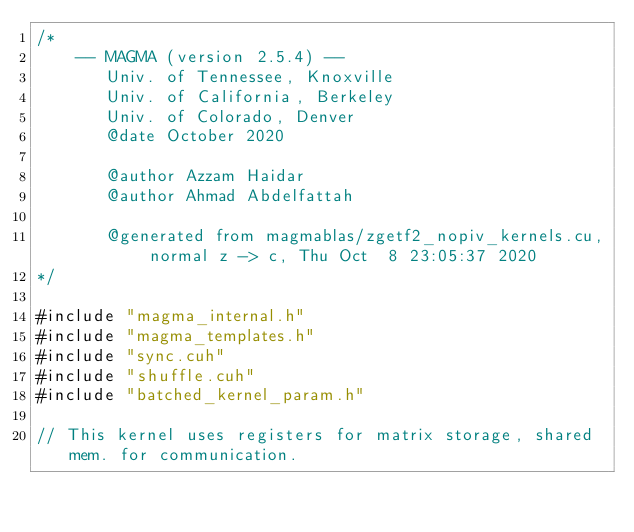<code> <loc_0><loc_0><loc_500><loc_500><_Cuda_>/*
    -- MAGMA (version 2.5.4) --
       Univ. of Tennessee, Knoxville
       Univ. of California, Berkeley
       Univ. of Colorado, Denver
       @date October 2020

       @author Azzam Haidar
       @author Ahmad Abdelfattah

       @generated from magmablas/zgetf2_nopiv_kernels.cu, normal z -> c, Thu Oct  8 23:05:37 2020
*/

#include "magma_internal.h"
#include "magma_templates.h"
#include "sync.cuh"
#include "shuffle.cuh"
#include "batched_kernel_param.h"

// This kernel uses registers for matrix storage, shared mem. for communication.</code> 